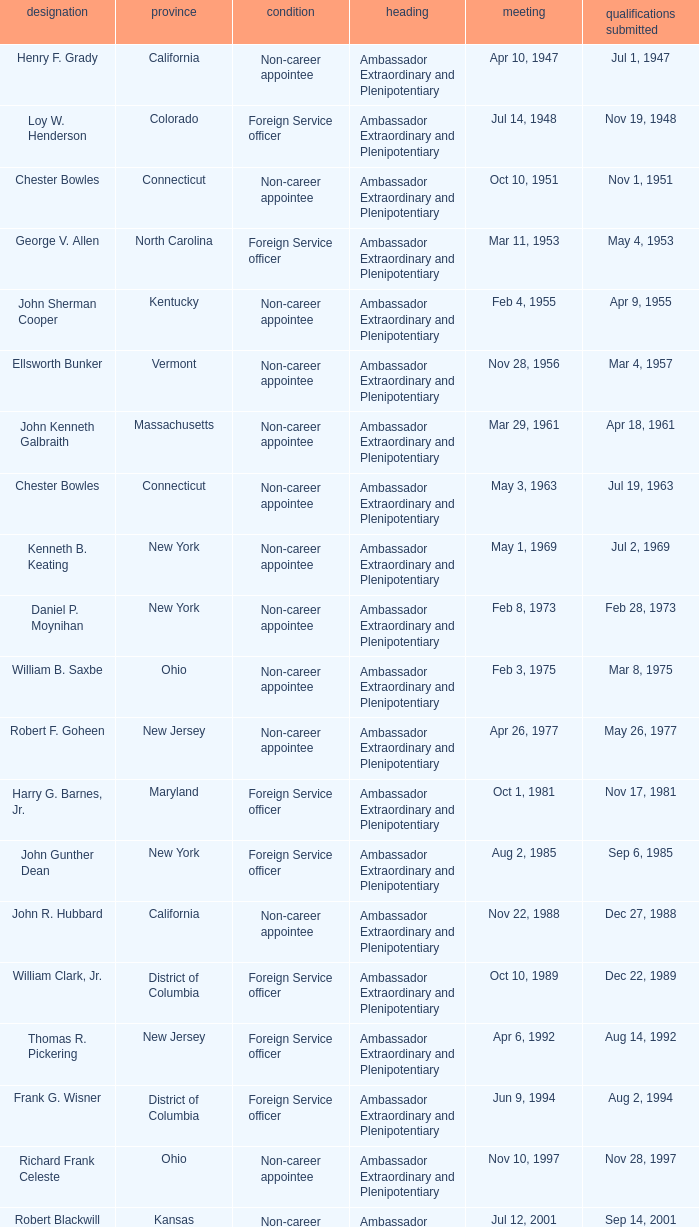What day were credentials presented for vermont? Mar 4, 1957. 